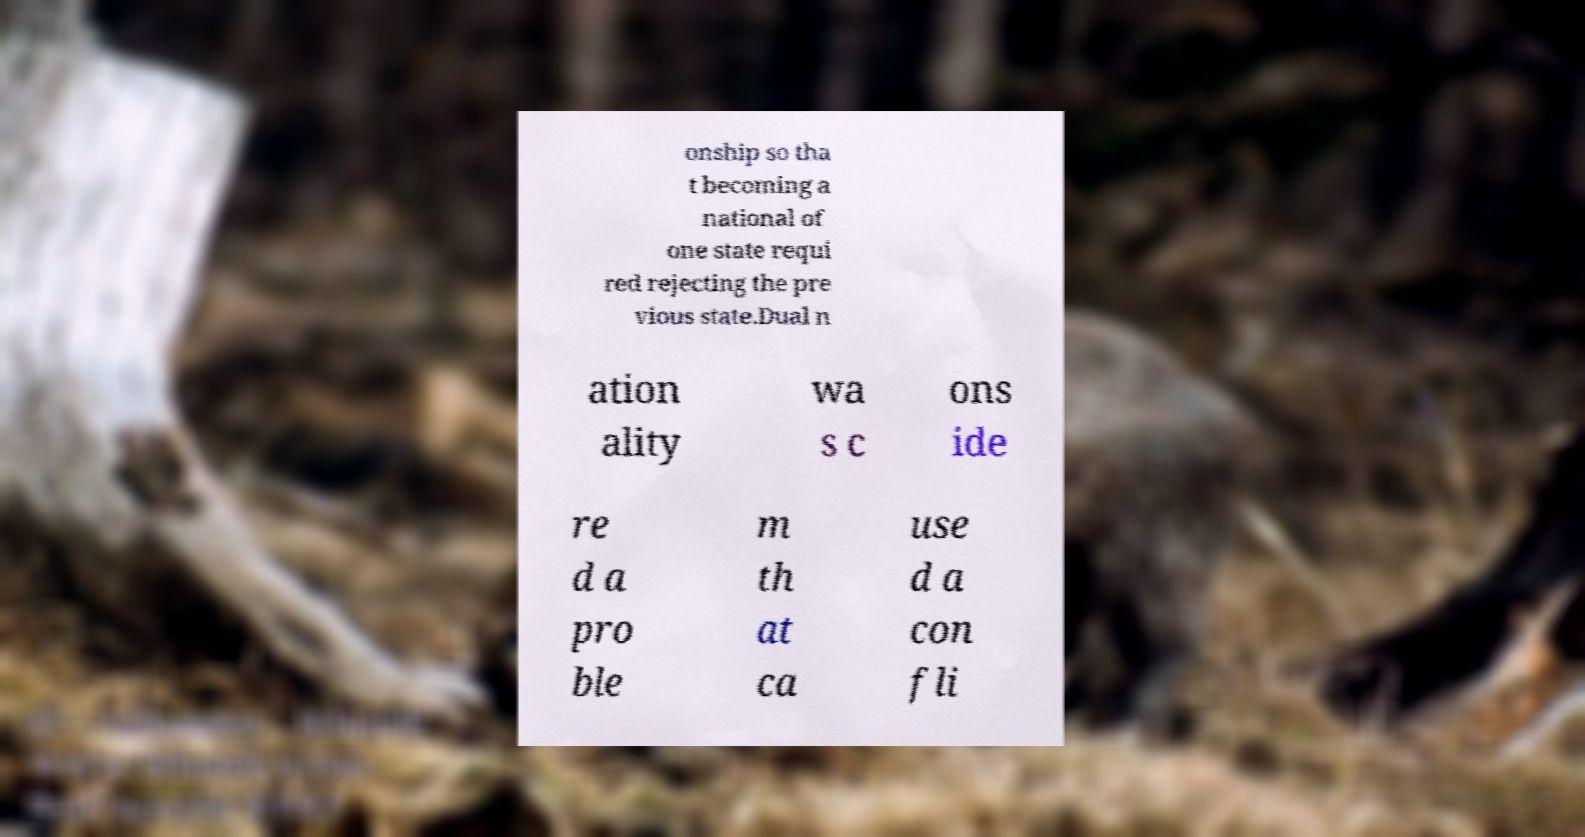There's text embedded in this image that I need extracted. Can you transcribe it verbatim? onship so tha t becoming a national of one state requi red rejecting the pre vious state.Dual n ation ality wa s c ons ide re d a pro ble m th at ca use d a con fli 